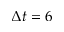<formula> <loc_0><loc_0><loc_500><loc_500>\Delta t = 6</formula> 